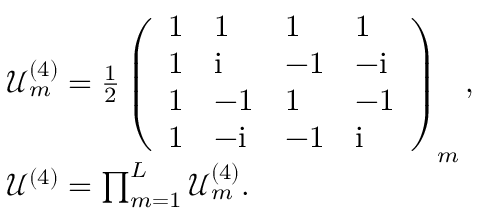<formula> <loc_0><loc_0><loc_500><loc_500>\begin{array} { r l } & { \mathcal { U } _ { m } ^ { ( 4 ) } = \frac { 1 } { 2 } \left ( \begin{array} { l l l l } { 1 } & { 1 } & { 1 } & { 1 } \\ { 1 } & { i } & { - 1 } & { - i } \\ { 1 } & { - 1 } & { 1 } & { - 1 } \\ { 1 } & { - i } & { - 1 } & { i } \end{array} \right ) _ { m } , } \\ & { \mathcal { U } ^ { ( 4 ) } = \prod _ { m = 1 } ^ { L } \mathcal { U } _ { m } ^ { ( 4 ) } . } \end{array}</formula> 